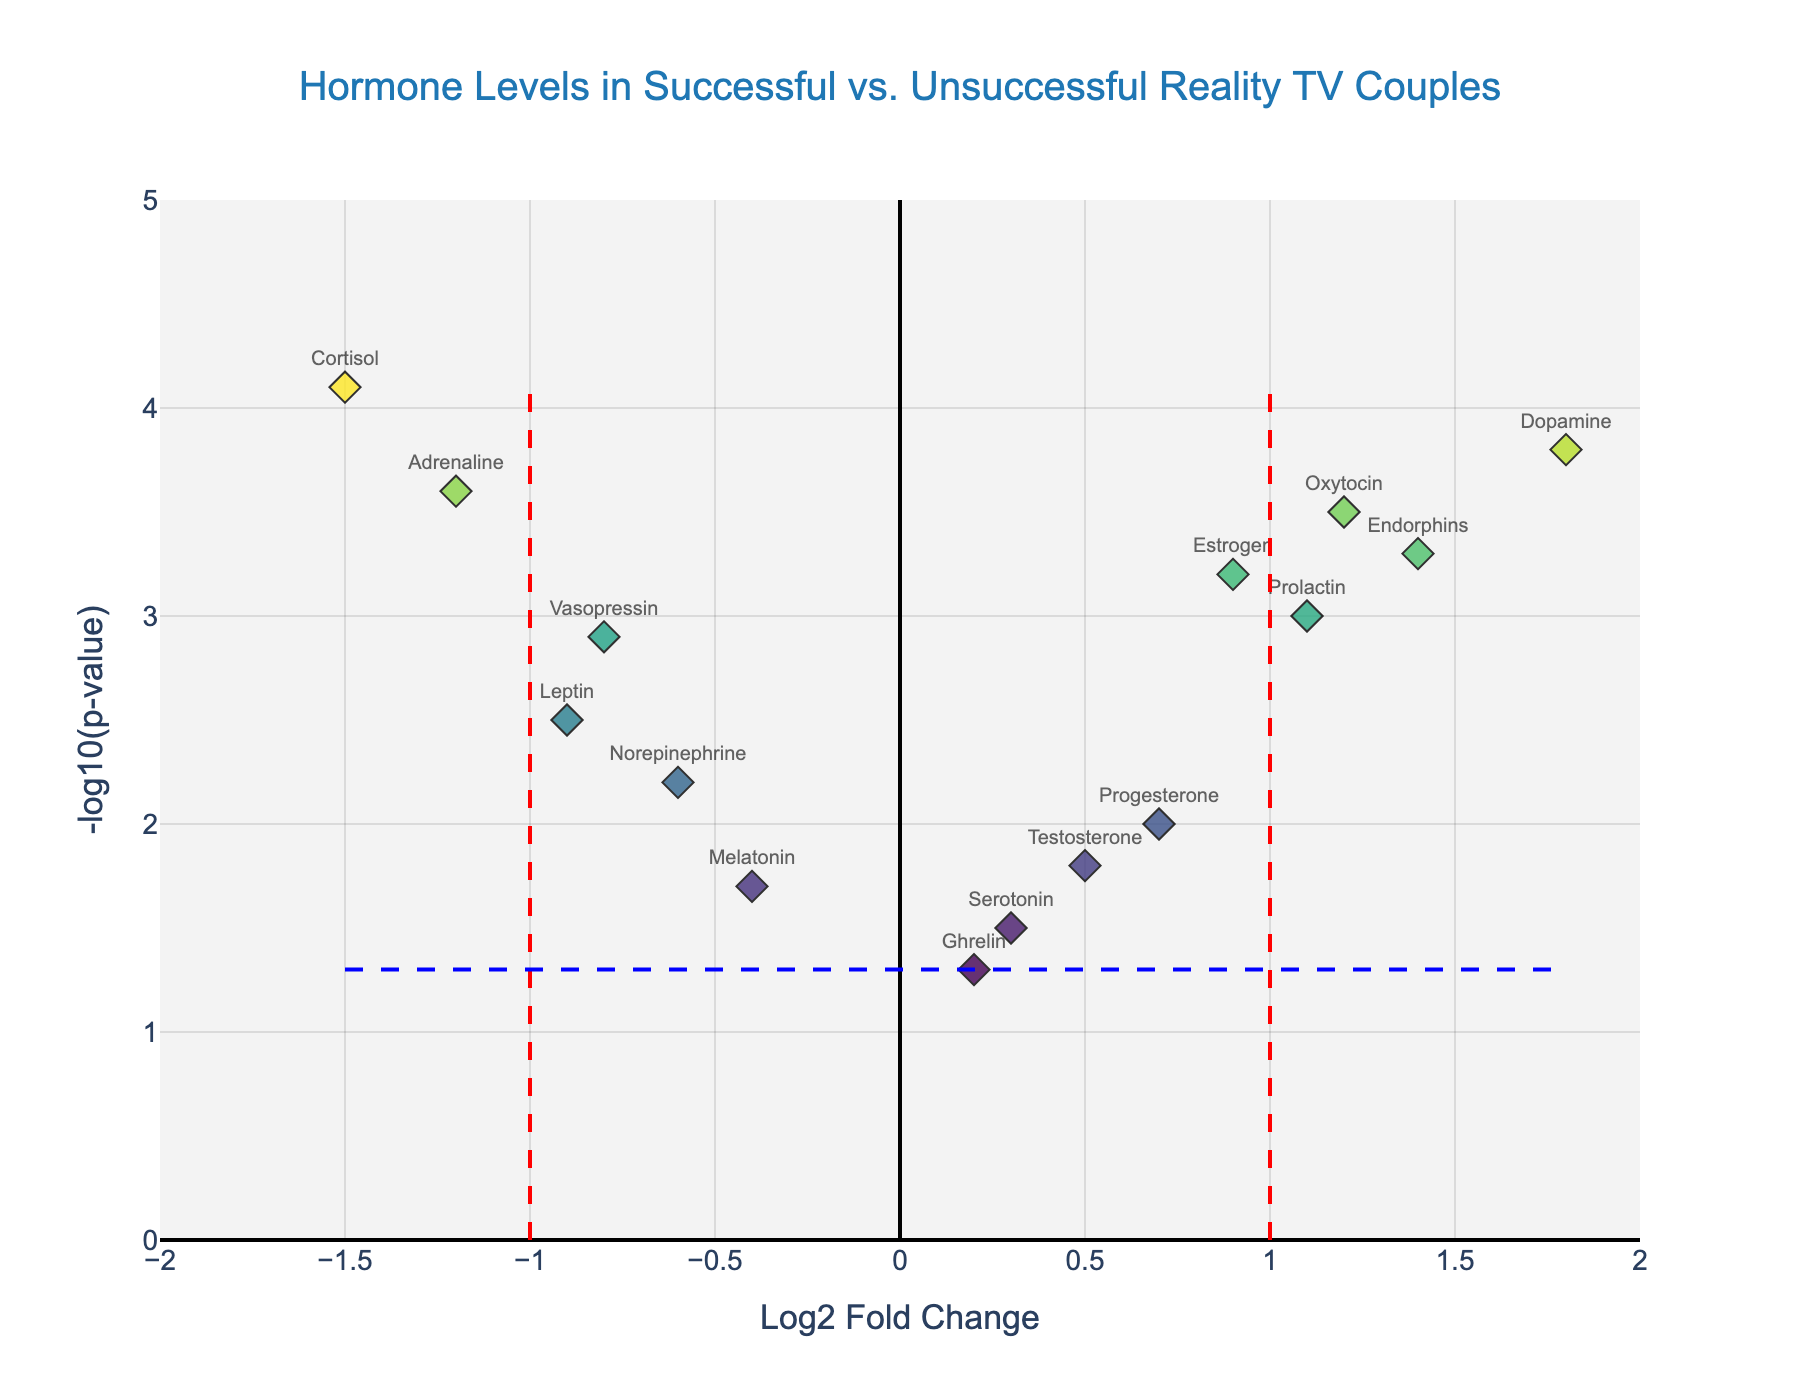What is the title of the plot? The title is usually displayed at the top of the plot. In this case, it should reflect what the plot is about.
Answer: Hormone Levels in Successful vs. Unsuccessful Reality TV Couples How many hormones have positive Log2 Fold Change? Count the number of hormones where the Log2 Fold Change is greater than zero.
Answer: 8 Which hormone has the highest -log10(p-value)? Identify the hormone with the highest value on the y-axis.
Answer: Cortisol Which hormones have a significant Log2 Fold Change? Significant changes are usually indicated by vertical dashed lines. Here, it's between -1 and 1. Count the points outside these lines.
Answer: Oxytocin, Vasopressin, Cortisol, Dopamine, Adrenaline, Endorphins, Leptin Are Oxytocin and Adrenaline expressed differently in successful couples compared to unsuccessful ones? Both hormones fall outside the significance threshold lines, indicating significant differences. Oxytocin shows a positive Log2 Fold Change, and Adrenaline shows a negative one.
Answer: Yes What is the Log2 Fold Change range covered in the plot? Look at the horizontal axis and find the minimum and maximum values displayed.
Answer: -2 to 2 How does the significance threshold appear on the plot? It is represented by a dashed blue horizontal line. Any dots above it indicate significant p-values.
Answer: Dashed blue line at -log10(p-value) = 1.301 Which hormone has a Log2 Fold Change close to zero but is still not significant? Identify the hormone near zero on the x-axis but below the significance threshold line.
Answer: Ghrelin What could a high -log10(p-value) but low Log2 Fold Change indicate? A high -log10(p-value) and low Log2 Fold Change suggest high significance in the test, but minimal actual change in hormone levels.
Answer: Minimal actual change but significant Comparing Dopamine and Vasopressin, which one shows a greater change and significance? Dopamine has higher values for both Log2 Fold Change and -log10(p-value) compared to Vasopressin.
Answer: Dopamine 